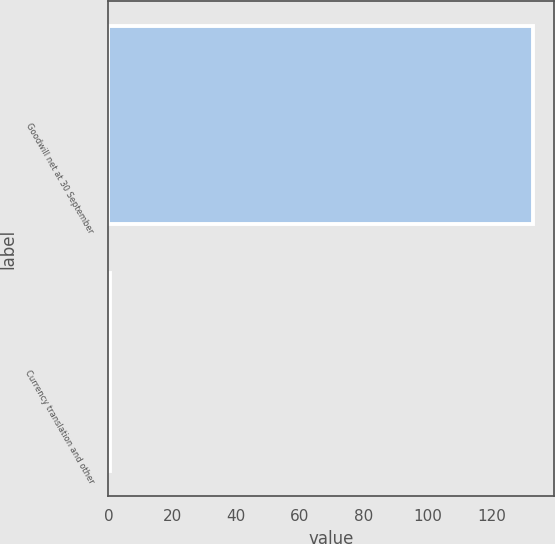Convert chart to OTSL. <chart><loc_0><loc_0><loc_500><loc_500><bar_chart><fcel>Goodwill net at 30 September<fcel>Currency translation and other<nl><fcel>133.1<fcel>0.5<nl></chart> 